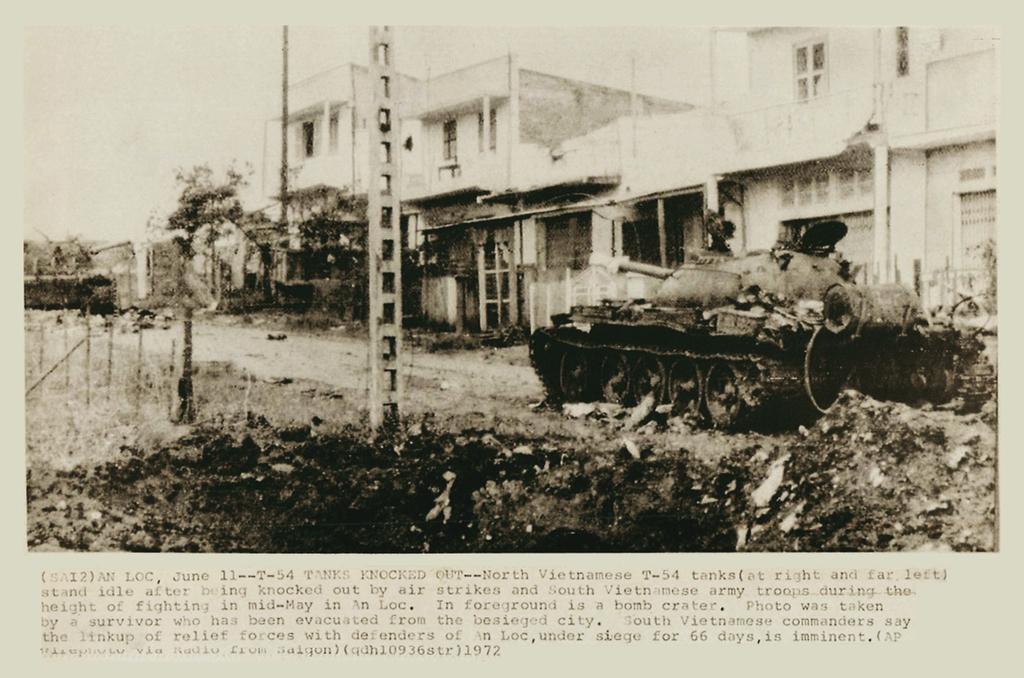What is depicted on the paper in the image? The paper contains a panzer and buildings. Where are the poles located in the image? The poles are on the left side of the image. What is written or printed at the bottom of the image? There is text at the bottom of the image. What type of jewel is shown in the image? There is no jewel present in the image. What shape is the money in the image? There is no money present in the image. 